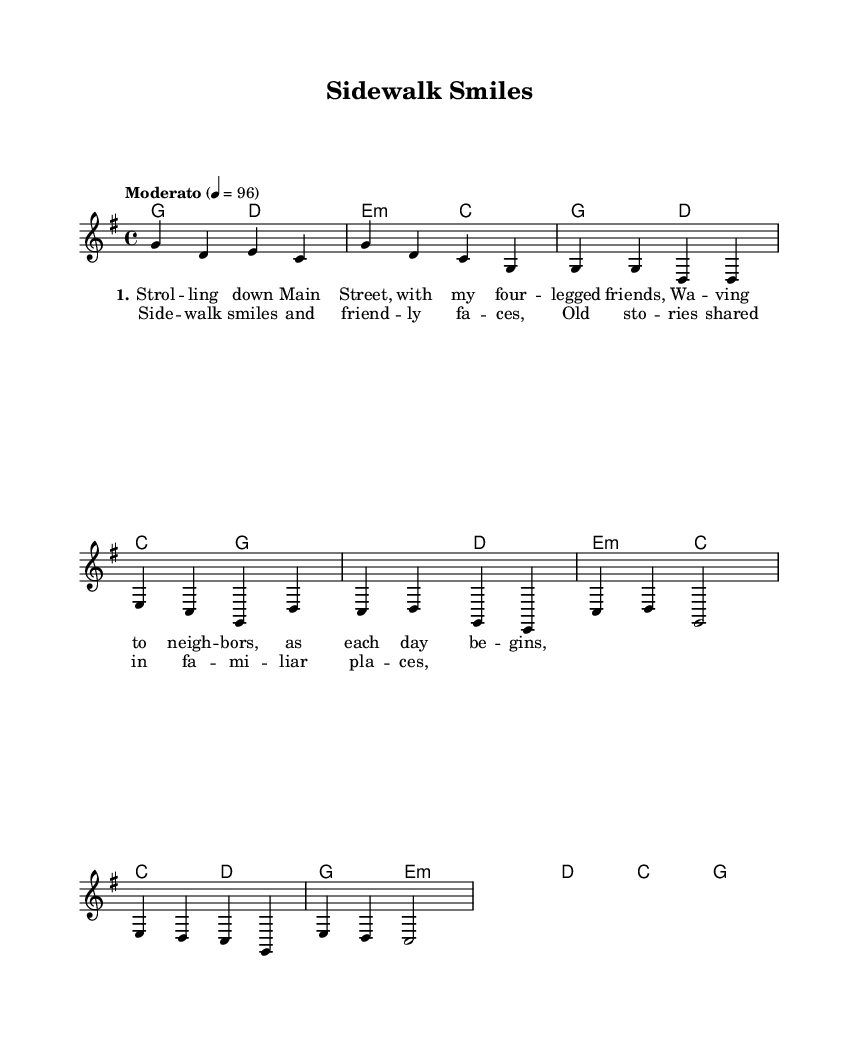What is the key signature of this music? The key signature is G major, which has one sharp (F#). This can be inferred directly from the key indication at the beginning of the score.
Answer: G major What is the time signature of this music? The time signature is 4/4, which is indicated at the beginning of the sheet music. It means there are four beats in each measure and a quarter note receives one beat.
Answer: 4/4 What is the tempo marking of this music? The tempo marking is "Moderato," which typically indicates a moderate pace. The specific beat rate of 96 is also noted, providing a precise tempo for performance.
Answer: Moderato How many measures are in the intro section? The intro section consists of four measures, which can be counted by assessing the groupings of notes before the first verse begins.
Answer: 4 Which section contains lyrics about walking down Main Street? The lyrics about walking down Main Street are found in Verse 1. The first line of this verse mentions "Strolling down Main Street." This directs us to the specific portion of the lyrics corresponding to the verse.
Answer: Verse 1 What is the note that starts the chorus? The chorus starts on the note C4, as indicated in the melody and melody line of the music corresponding to the chorus lyrics.
Answer: C4 What kind of song structure is used in this piece? The song uses a common folk structure, which consists of verses and a chorus, typically alternating between these sections to create a narrative flow. This is a typical format for folk songs celebrating simple life themes.
Answer: Verse - Chorus 